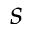Convert formula to latex. <formula><loc_0><loc_0><loc_500><loc_500>s</formula> 